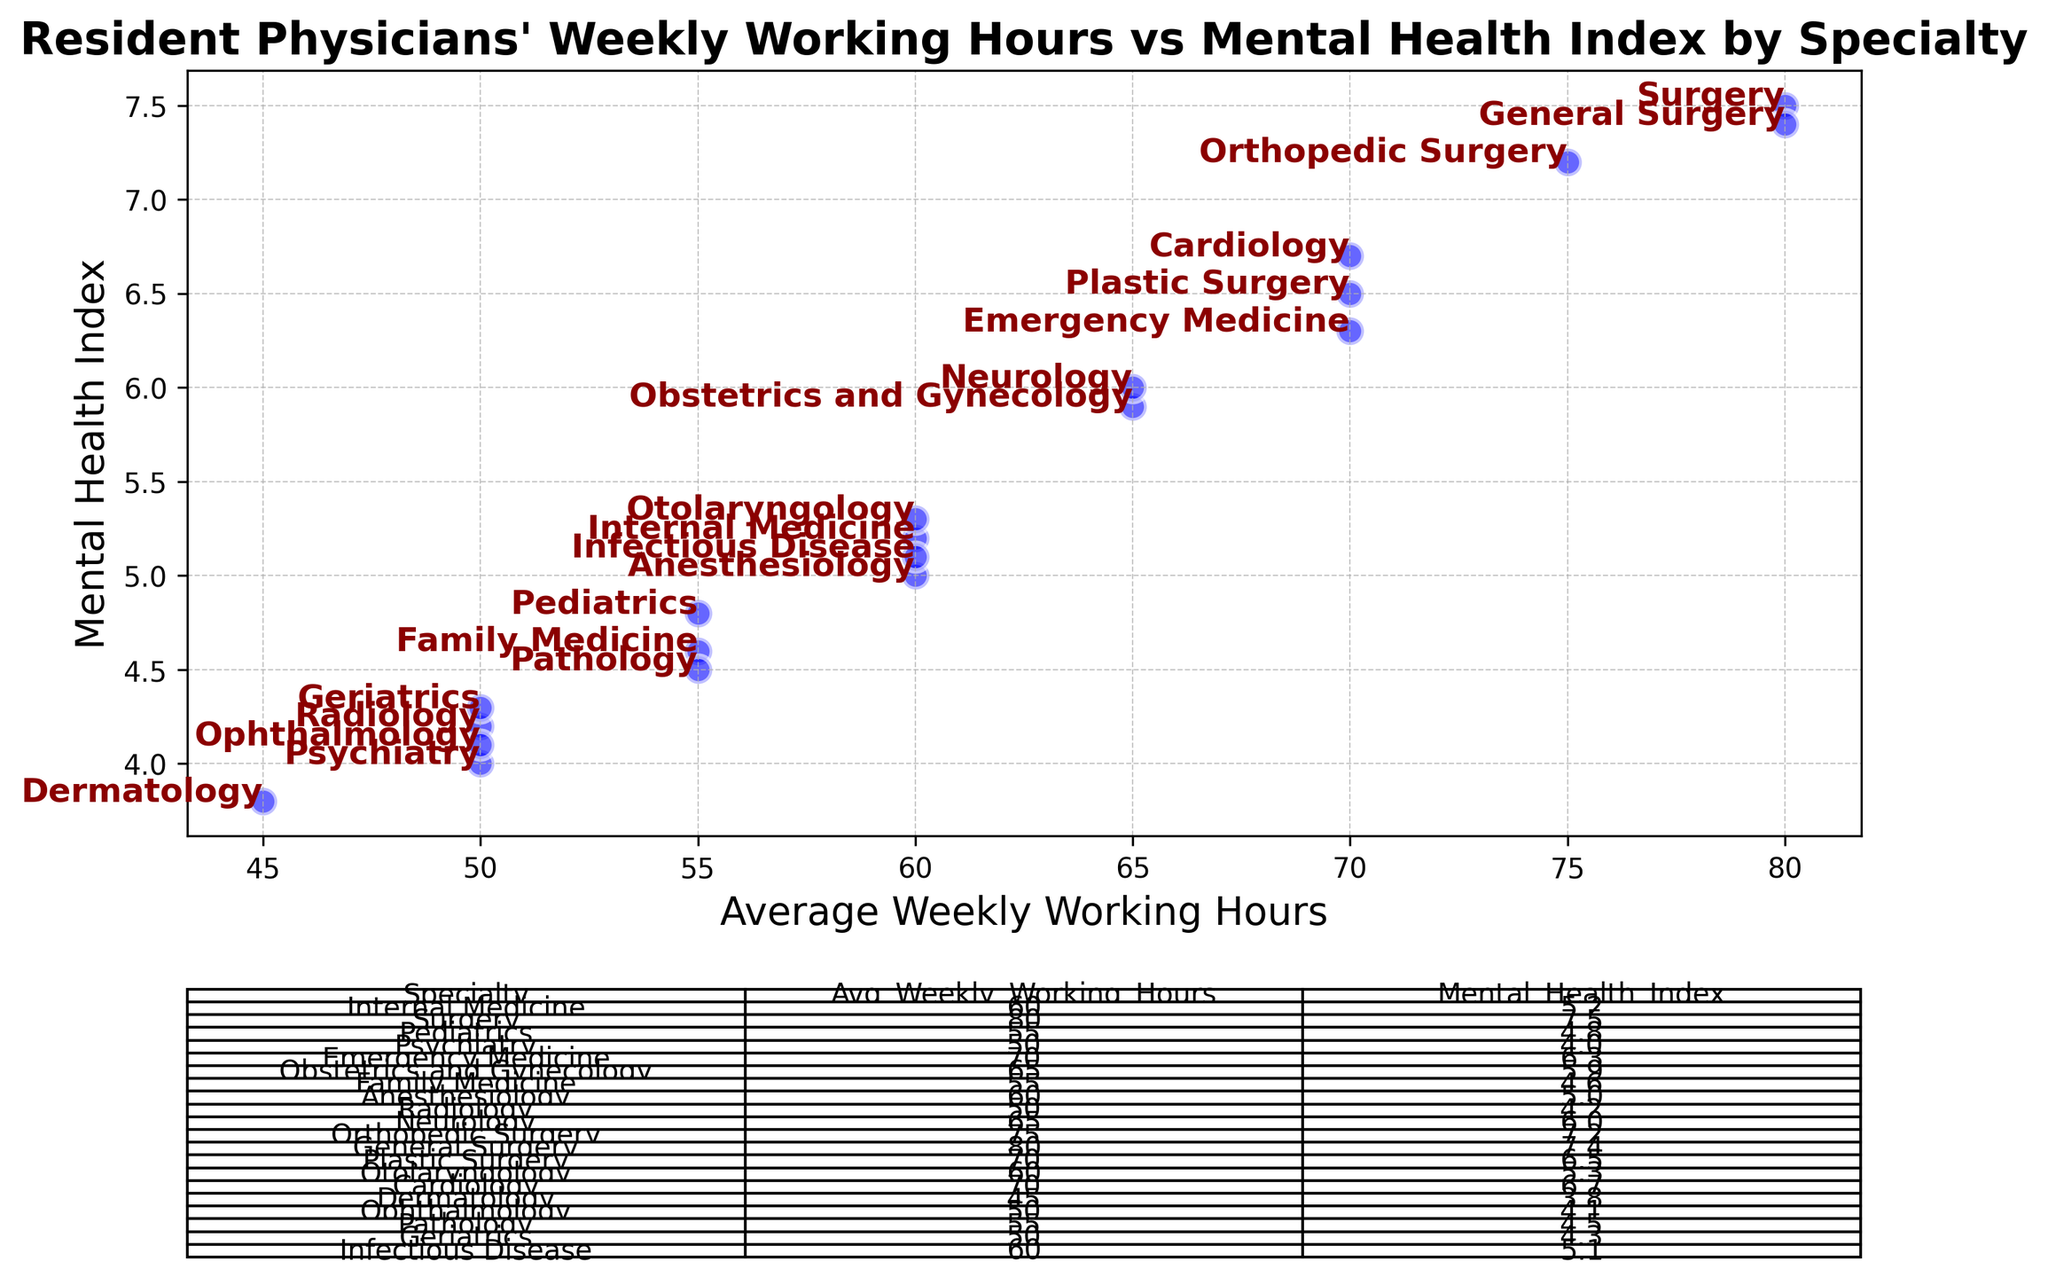Which speciality has the highest average weekly working hours? By looking at the chart, the specialty with the highest data point on the x-axis (Average Weekly Working Hours) is Surgery and General Surgery, both with 80 hours.
Answer: Surgery and General Surgery Which specialty has the lowest mental health index? The specialty with the lowest data point on the y-axis (Mental Health Index) is Dermatology, with a value of 3.8.
Answer: Dermatology What is the difference in average weekly working hours between Psychiatry and Emergency Medicine? Psychiatry averages 50 weekly working hours, and Emergency Medicine averages 70. The difference is 70 - 50 = 20.
Answer: 20 Which specialty has the closest mental health index to an average weekly working hours of 60? Looking at the chart, Infectious Disease has a working hour of 60 with a Mental Health Index of 5.1, which is the closest point.
Answer: Infectious Disease Which specialties have an average weekly working hours of 50? The specialties with data points aligned with 50 hours on the x-axis are Psychiatry, Radiology, Ophthalmology, and Geriatrics.
Answer: Psychiatry, Radiology, Ophthalmology, Geriatrics How many specialties have an average weekly working hours of 55 or fewer? The specialties with data points on or below 55 on the x-axis are Pediatrics (55), Family Medicine (55), Radiology (50), Psychiatry (50), Dermatology (45), Ophthalmology (50), Pathology (55), Geriatrics (50). Counting these gives 8 specialties.
Answer: 8 Is there a correlation between the average weekly working hours and the mental health index? Observing the chart, there is a general trend where the mental health index tends to increase as average weekly working hours increase. For example, Surgery and General Surgery have the highest working hours and mental health indices, while Dermatology has both the lowest working hours and mental health index.
Answer: Yes Compare the average weekly working hours and mental health index between Internal Medicine and Cardiology. Internal Medicine has an average of 60 working hours and a mental health index of 5.2, while Cardiology has 70 working hours and a mental health index of 6.7.
Answer: Internal: 60 hours, 5.2 index; Cardiology: 70 hours, 6.7 index Calculate the average mental health index of the specialties with equal or more than 70 average weekly working hours. The specialties are Surgery (7.5), Emergency Medicine (6.3), General Surgery (7.4), Plastic Surgery (6.5), Orthopedic Surgery (7.2), and Cardiology (6.7). Average = (7.5 + 6.3 + 7.4 + 6.5 + 7.2 + 6.7) / 6 = 6.93.
Answer: 6.93 